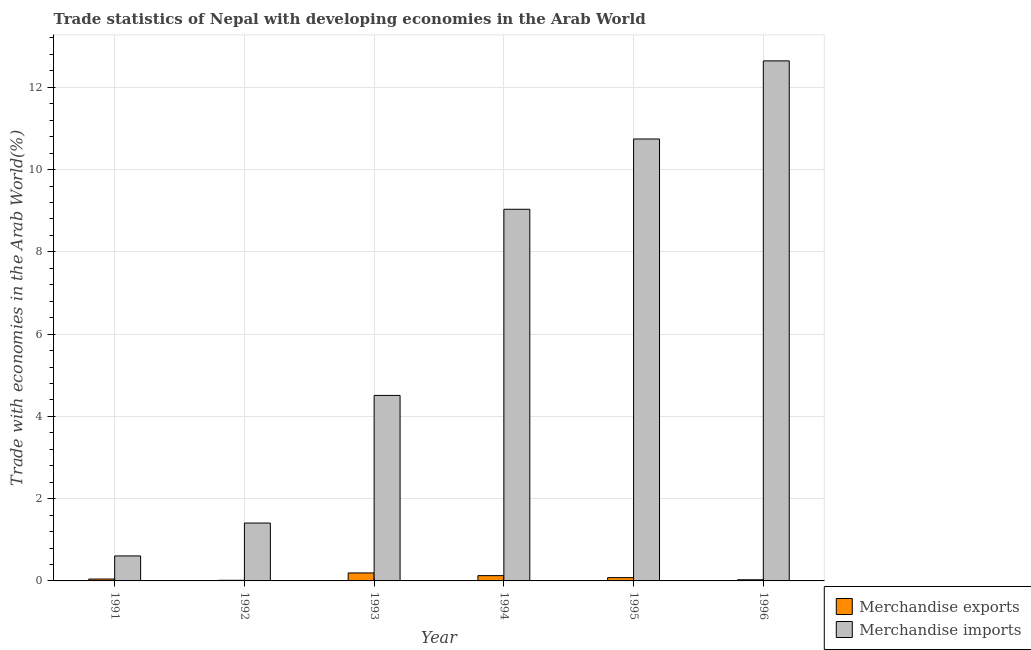What is the merchandise imports in 1992?
Offer a very short reply. 1.41. Across all years, what is the maximum merchandise exports?
Provide a succinct answer. 0.19. Across all years, what is the minimum merchandise exports?
Offer a terse response. 0.02. In which year was the merchandise imports maximum?
Provide a succinct answer. 1996. In which year was the merchandise exports minimum?
Offer a very short reply. 1992. What is the total merchandise exports in the graph?
Ensure brevity in your answer.  0.49. What is the difference between the merchandise imports in 1992 and that in 1996?
Offer a terse response. -11.23. What is the difference between the merchandise exports in 1994 and the merchandise imports in 1993?
Give a very brief answer. -0.07. What is the average merchandise exports per year?
Offer a very short reply. 0.08. In the year 1995, what is the difference between the merchandise imports and merchandise exports?
Provide a short and direct response. 0. What is the ratio of the merchandise imports in 1992 to that in 1995?
Offer a very short reply. 0.13. Is the merchandise exports in 1991 less than that in 1994?
Your response must be concise. Yes. What is the difference between the highest and the second highest merchandise exports?
Provide a succinct answer. 0.07. What is the difference between the highest and the lowest merchandise exports?
Your answer should be very brief. 0.18. In how many years, is the merchandise imports greater than the average merchandise imports taken over all years?
Your answer should be very brief. 3. What does the 1st bar from the right in 1991 represents?
Provide a succinct answer. Merchandise imports. How many bars are there?
Make the answer very short. 12. How many years are there in the graph?
Provide a succinct answer. 6. Does the graph contain grids?
Provide a short and direct response. Yes. How many legend labels are there?
Provide a short and direct response. 2. What is the title of the graph?
Ensure brevity in your answer.  Trade statistics of Nepal with developing economies in the Arab World. Does "Male" appear as one of the legend labels in the graph?
Keep it short and to the point. No. What is the label or title of the Y-axis?
Keep it short and to the point. Trade with economies in the Arab World(%). What is the Trade with economies in the Arab World(%) in Merchandise exports in 1991?
Make the answer very short. 0.05. What is the Trade with economies in the Arab World(%) in Merchandise imports in 1991?
Keep it short and to the point. 0.61. What is the Trade with economies in the Arab World(%) in Merchandise exports in 1992?
Your answer should be compact. 0.02. What is the Trade with economies in the Arab World(%) in Merchandise imports in 1992?
Ensure brevity in your answer.  1.41. What is the Trade with economies in the Arab World(%) of Merchandise exports in 1993?
Offer a terse response. 0.19. What is the Trade with economies in the Arab World(%) in Merchandise imports in 1993?
Provide a succinct answer. 4.51. What is the Trade with economies in the Arab World(%) of Merchandise exports in 1994?
Offer a very short reply. 0.13. What is the Trade with economies in the Arab World(%) in Merchandise imports in 1994?
Your answer should be very brief. 9.03. What is the Trade with economies in the Arab World(%) of Merchandise exports in 1995?
Offer a terse response. 0.08. What is the Trade with economies in the Arab World(%) in Merchandise imports in 1995?
Ensure brevity in your answer.  10.74. What is the Trade with economies in the Arab World(%) in Merchandise exports in 1996?
Make the answer very short. 0.03. What is the Trade with economies in the Arab World(%) in Merchandise imports in 1996?
Your answer should be compact. 12.64. Across all years, what is the maximum Trade with economies in the Arab World(%) of Merchandise exports?
Offer a very short reply. 0.19. Across all years, what is the maximum Trade with economies in the Arab World(%) of Merchandise imports?
Offer a very short reply. 12.64. Across all years, what is the minimum Trade with economies in the Arab World(%) of Merchandise exports?
Give a very brief answer. 0.02. Across all years, what is the minimum Trade with economies in the Arab World(%) of Merchandise imports?
Provide a succinct answer. 0.61. What is the total Trade with economies in the Arab World(%) of Merchandise exports in the graph?
Keep it short and to the point. 0.49. What is the total Trade with economies in the Arab World(%) in Merchandise imports in the graph?
Ensure brevity in your answer.  38.94. What is the difference between the Trade with economies in the Arab World(%) of Merchandise exports in 1991 and that in 1992?
Keep it short and to the point. 0.03. What is the difference between the Trade with economies in the Arab World(%) in Merchandise imports in 1991 and that in 1992?
Give a very brief answer. -0.8. What is the difference between the Trade with economies in the Arab World(%) of Merchandise exports in 1991 and that in 1993?
Make the answer very short. -0.15. What is the difference between the Trade with economies in the Arab World(%) in Merchandise imports in 1991 and that in 1993?
Offer a terse response. -3.9. What is the difference between the Trade with economies in the Arab World(%) of Merchandise exports in 1991 and that in 1994?
Provide a succinct answer. -0.08. What is the difference between the Trade with economies in the Arab World(%) of Merchandise imports in 1991 and that in 1994?
Your answer should be very brief. -8.43. What is the difference between the Trade with economies in the Arab World(%) in Merchandise exports in 1991 and that in 1995?
Offer a terse response. -0.03. What is the difference between the Trade with economies in the Arab World(%) of Merchandise imports in 1991 and that in 1995?
Your response must be concise. -10.14. What is the difference between the Trade with economies in the Arab World(%) of Merchandise exports in 1991 and that in 1996?
Your response must be concise. 0.02. What is the difference between the Trade with economies in the Arab World(%) in Merchandise imports in 1991 and that in 1996?
Offer a terse response. -12.03. What is the difference between the Trade with economies in the Arab World(%) of Merchandise exports in 1992 and that in 1993?
Offer a very short reply. -0.18. What is the difference between the Trade with economies in the Arab World(%) in Merchandise imports in 1992 and that in 1993?
Your response must be concise. -3.1. What is the difference between the Trade with economies in the Arab World(%) of Merchandise exports in 1992 and that in 1994?
Give a very brief answer. -0.11. What is the difference between the Trade with economies in the Arab World(%) in Merchandise imports in 1992 and that in 1994?
Provide a short and direct response. -7.63. What is the difference between the Trade with economies in the Arab World(%) in Merchandise exports in 1992 and that in 1995?
Keep it short and to the point. -0.06. What is the difference between the Trade with economies in the Arab World(%) in Merchandise imports in 1992 and that in 1995?
Give a very brief answer. -9.34. What is the difference between the Trade with economies in the Arab World(%) of Merchandise exports in 1992 and that in 1996?
Keep it short and to the point. -0.01. What is the difference between the Trade with economies in the Arab World(%) of Merchandise imports in 1992 and that in 1996?
Provide a short and direct response. -11.23. What is the difference between the Trade with economies in the Arab World(%) of Merchandise exports in 1993 and that in 1994?
Ensure brevity in your answer.  0.07. What is the difference between the Trade with economies in the Arab World(%) in Merchandise imports in 1993 and that in 1994?
Keep it short and to the point. -4.53. What is the difference between the Trade with economies in the Arab World(%) of Merchandise exports in 1993 and that in 1995?
Give a very brief answer. 0.11. What is the difference between the Trade with economies in the Arab World(%) in Merchandise imports in 1993 and that in 1995?
Keep it short and to the point. -6.23. What is the difference between the Trade with economies in the Arab World(%) of Merchandise exports in 1993 and that in 1996?
Ensure brevity in your answer.  0.17. What is the difference between the Trade with economies in the Arab World(%) in Merchandise imports in 1993 and that in 1996?
Your answer should be very brief. -8.13. What is the difference between the Trade with economies in the Arab World(%) in Merchandise exports in 1994 and that in 1995?
Ensure brevity in your answer.  0.05. What is the difference between the Trade with economies in the Arab World(%) in Merchandise imports in 1994 and that in 1995?
Provide a succinct answer. -1.71. What is the difference between the Trade with economies in the Arab World(%) in Merchandise exports in 1994 and that in 1996?
Offer a terse response. 0.1. What is the difference between the Trade with economies in the Arab World(%) in Merchandise imports in 1994 and that in 1996?
Your answer should be very brief. -3.61. What is the difference between the Trade with economies in the Arab World(%) of Merchandise exports in 1995 and that in 1996?
Offer a very short reply. 0.05. What is the difference between the Trade with economies in the Arab World(%) in Merchandise imports in 1995 and that in 1996?
Make the answer very short. -1.9. What is the difference between the Trade with economies in the Arab World(%) in Merchandise exports in 1991 and the Trade with economies in the Arab World(%) in Merchandise imports in 1992?
Offer a very short reply. -1.36. What is the difference between the Trade with economies in the Arab World(%) in Merchandise exports in 1991 and the Trade with economies in the Arab World(%) in Merchandise imports in 1993?
Make the answer very short. -4.46. What is the difference between the Trade with economies in the Arab World(%) of Merchandise exports in 1991 and the Trade with economies in the Arab World(%) of Merchandise imports in 1994?
Your answer should be very brief. -8.99. What is the difference between the Trade with economies in the Arab World(%) in Merchandise exports in 1991 and the Trade with economies in the Arab World(%) in Merchandise imports in 1995?
Keep it short and to the point. -10.7. What is the difference between the Trade with economies in the Arab World(%) in Merchandise exports in 1991 and the Trade with economies in the Arab World(%) in Merchandise imports in 1996?
Your response must be concise. -12.6. What is the difference between the Trade with economies in the Arab World(%) of Merchandise exports in 1992 and the Trade with economies in the Arab World(%) of Merchandise imports in 1993?
Ensure brevity in your answer.  -4.49. What is the difference between the Trade with economies in the Arab World(%) in Merchandise exports in 1992 and the Trade with economies in the Arab World(%) in Merchandise imports in 1994?
Your answer should be very brief. -9.02. What is the difference between the Trade with economies in the Arab World(%) in Merchandise exports in 1992 and the Trade with economies in the Arab World(%) in Merchandise imports in 1995?
Offer a terse response. -10.73. What is the difference between the Trade with economies in the Arab World(%) in Merchandise exports in 1992 and the Trade with economies in the Arab World(%) in Merchandise imports in 1996?
Ensure brevity in your answer.  -12.63. What is the difference between the Trade with economies in the Arab World(%) in Merchandise exports in 1993 and the Trade with economies in the Arab World(%) in Merchandise imports in 1994?
Your response must be concise. -8.84. What is the difference between the Trade with economies in the Arab World(%) in Merchandise exports in 1993 and the Trade with economies in the Arab World(%) in Merchandise imports in 1995?
Your answer should be very brief. -10.55. What is the difference between the Trade with economies in the Arab World(%) in Merchandise exports in 1993 and the Trade with economies in the Arab World(%) in Merchandise imports in 1996?
Offer a very short reply. -12.45. What is the difference between the Trade with economies in the Arab World(%) in Merchandise exports in 1994 and the Trade with economies in the Arab World(%) in Merchandise imports in 1995?
Your response must be concise. -10.61. What is the difference between the Trade with economies in the Arab World(%) of Merchandise exports in 1994 and the Trade with economies in the Arab World(%) of Merchandise imports in 1996?
Offer a very short reply. -12.51. What is the difference between the Trade with economies in the Arab World(%) in Merchandise exports in 1995 and the Trade with economies in the Arab World(%) in Merchandise imports in 1996?
Give a very brief answer. -12.56. What is the average Trade with economies in the Arab World(%) in Merchandise exports per year?
Your response must be concise. 0.08. What is the average Trade with economies in the Arab World(%) in Merchandise imports per year?
Keep it short and to the point. 6.49. In the year 1991, what is the difference between the Trade with economies in the Arab World(%) in Merchandise exports and Trade with economies in the Arab World(%) in Merchandise imports?
Give a very brief answer. -0.56. In the year 1992, what is the difference between the Trade with economies in the Arab World(%) of Merchandise exports and Trade with economies in the Arab World(%) of Merchandise imports?
Provide a short and direct response. -1.39. In the year 1993, what is the difference between the Trade with economies in the Arab World(%) in Merchandise exports and Trade with economies in the Arab World(%) in Merchandise imports?
Ensure brevity in your answer.  -4.32. In the year 1994, what is the difference between the Trade with economies in the Arab World(%) in Merchandise exports and Trade with economies in the Arab World(%) in Merchandise imports?
Make the answer very short. -8.91. In the year 1995, what is the difference between the Trade with economies in the Arab World(%) in Merchandise exports and Trade with economies in the Arab World(%) in Merchandise imports?
Offer a very short reply. -10.66. In the year 1996, what is the difference between the Trade with economies in the Arab World(%) of Merchandise exports and Trade with economies in the Arab World(%) of Merchandise imports?
Keep it short and to the point. -12.61. What is the ratio of the Trade with economies in the Arab World(%) in Merchandise exports in 1991 to that in 1992?
Make the answer very short. 3.03. What is the ratio of the Trade with economies in the Arab World(%) of Merchandise imports in 1991 to that in 1992?
Your response must be concise. 0.43. What is the ratio of the Trade with economies in the Arab World(%) in Merchandise exports in 1991 to that in 1993?
Your answer should be compact. 0.24. What is the ratio of the Trade with economies in the Arab World(%) in Merchandise imports in 1991 to that in 1993?
Offer a very short reply. 0.13. What is the ratio of the Trade with economies in the Arab World(%) of Merchandise exports in 1991 to that in 1994?
Give a very brief answer. 0.36. What is the ratio of the Trade with economies in the Arab World(%) of Merchandise imports in 1991 to that in 1994?
Your response must be concise. 0.07. What is the ratio of the Trade with economies in the Arab World(%) in Merchandise exports in 1991 to that in 1995?
Keep it short and to the point. 0.58. What is the ratio of the Trade with economies in the Arab World(%) in Merchandise imports in 1991 to that in 1995?
Provide a short and direct response. 0.06. What is the ratio of the Trade with economies in the Arab World(%) in Merchandise exports in 1991 to that in 1996?
Make the answer very short. 1.65. What is the ratio of the Trade with economies in the Arab World(%) in Merchandise imports in 1991 to that in 1996?
Ensure brevity in your answer.  0.05. What is the ratio of the Trade with economies in the Arab World(%) of Merchandise exports in 1992 to that in 1993?
Give a very brief answer. 0.08. What is the ratio of the Trade with economies in the Arab World(%) in Merchandise imports in 1992 to that in 1993?
Your answer should be compact. 0.31. What is the ratio of the Trade with economies in the Arab World(%) of Merchandise exports in 1992 to that in 1994?
Offer a terse response. 0.12. What is the ratio of the Trade with economies in the Arab World(%) in Merchandise imports in 1992 to that in 1994?
Your answer should be very brief. 0.16. What is the ratio of the Trade with economies in the Arab World(%) in Merchandise exports in 1992 to that in 1995?
Your answer should be very brief. 0.19. What is the ratio of the Trade with economies in the Arab World(%) of Merchandise imports in 1992 to that in 1995?
Your answer should be compact. 0.13. What is the ratio of the Trade with economies in the Arab World(%) of Merchandise exports in 1992 to that in 1996?
Provide a short and direct response. 0.55. What is the ratio of the Trade with economies in the Arab World(%) in Merchandise imports in 1992 to that in 1996?
Provide a short and direct response. 0.11. What is the ratio of the Trade with economies in the Arab World(%) in Merchandise exports in 1993 to that in 1994?
Provide a short and direct response. 1.51. What is the ratio of the Trade with economies in the Arab World(%) of Merchandise imports in 1993 to that in 1994?
Offer a very short reply. 0.5. What is the ratio of the Trade with economies in the Arab World(%) in Merchandise exports in 1993 to that in 1995?
Make the answer very short. 2.43. What is the ratio of the Trade with economies in the Arab World(%) in Merchandise imports in 1993 to that in 1995?
Give a very brief answer. 0.42. What is the ratio of the Trade with economies in the Arab World(%) of Merchandise exports in 1993 to that in 1996?
Give a very brief answer. 6.99. What is the ratio of the Trade with economies in the Arab World(%) of Merchandise imports in 1993 to that in 1996?
Your answer should be compact. 0.36. What is the ratio of the Trade with economies in the Arab World(%) in Merchandise exports in 1994 to that in 1995?
Offer a terse response. 1.61. What is the ratio of the Trade with economies in the Arab World(%) of Merchandise imports in 1994 to that in 1995?
Ensure brevity in your answer.  0.84. What is the ratio of the Trade with economies in the Arab World(%) of Merchandise exports in 1994 to that in 1996?
Your answer should be very brief. 4.63. What is the ratio of the Trade with economies in the Arab World(%) in Merchandise imports in 1994 to that in 1996?
Offer a terse response. 0.71. What is the ratio of the Trade with economies in the Arab World(%) of Merchandise exports in 1995 to that in 1996?
Your response must be concise. 2.87. What is the ratio of the Trade with economies in the Arab World(%) of Merchandise imports in 1995 to that in 1996?
Your answer should be very brief. 0.85. What is the difference between the highest and the second highest Trade with economies in the Arab World(%) of Merchandise exports?
Your response must be concise. 0.07. What is the difference between the highest and the second highest Trade with economies in the Arab World(%) of Merchandise imports?
Make the answer very short. 1.9. What is the difference between the highest and the lowest Trade with economies in the Arab World(%) of Merchandise exports?
Offer a very short reply. 0.18. What is the difference between the highest and the lowest Trade with economies in the Arab World(%) of Merchandise imports?
Make the answer very short. 12.03. 